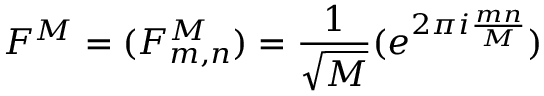<formula> <loc_0><loc_0><loc_500><loc_500>F ^ { M } = ( F _ { m , n } ^ { M } ) = \frac { 1 } { \sqrt { M } } ( e ^ { 2 \pi i \frac { m n } { M } } )</formula> 